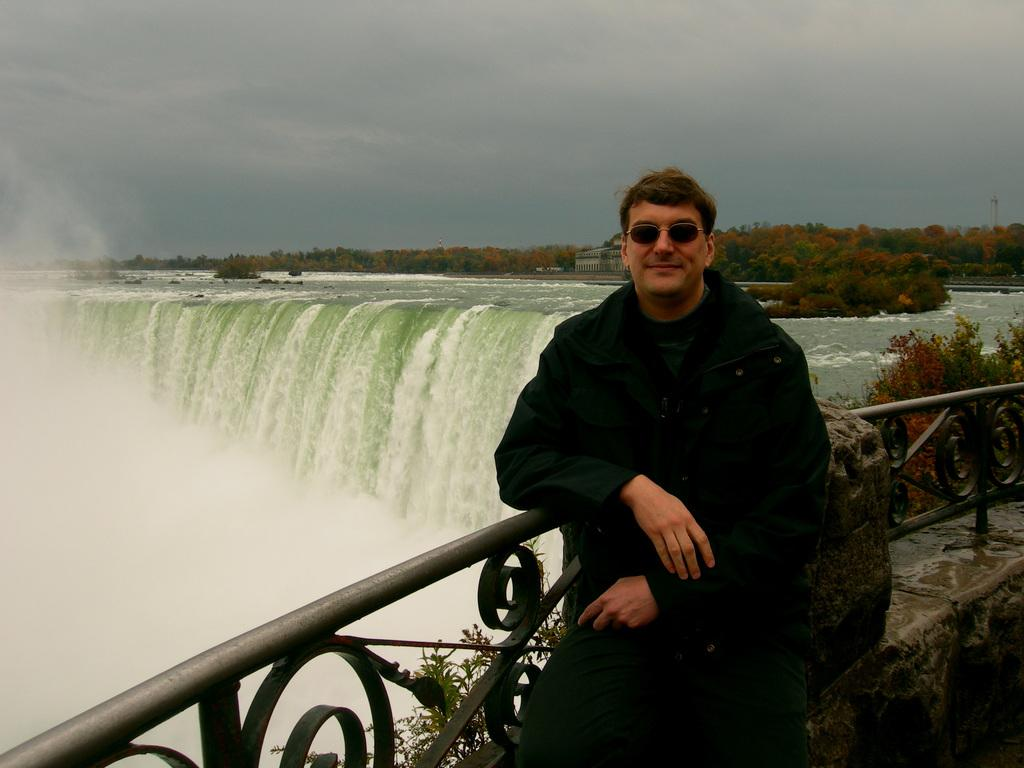What is the main subject of the image? There is a man in the image. What is the man doing in the image? The man has his hand on a fence. What can be seen in the background of the image? There is a waterfall, trees, buildings, and clouds in the sky in the background of the image. What type of brick is being used to build the sheep in the image? There are no sheep or bricks present in the image. 